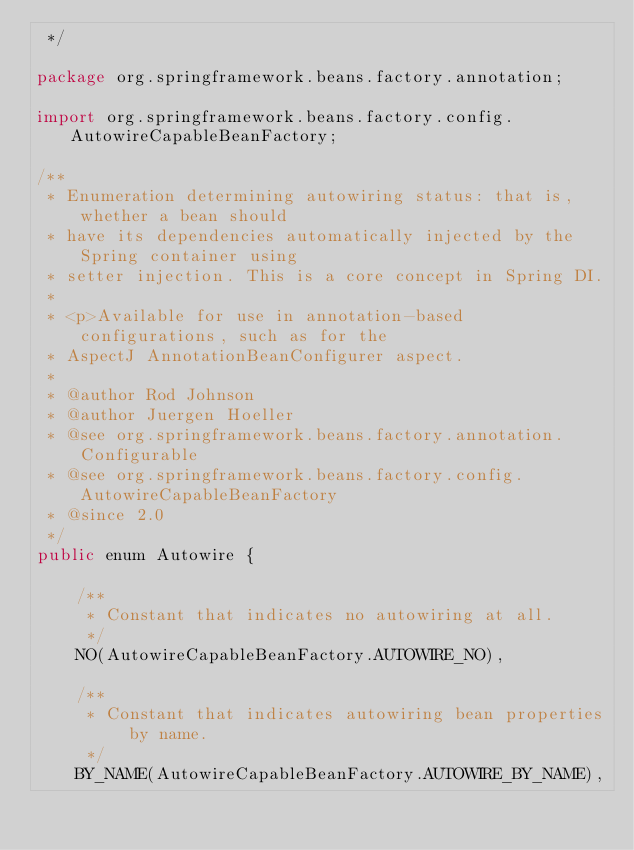<code> <loc_0><loc_0><loc_500><loc_500><_Java_> */

package org.springframework.beans.factory.annotation;

import org.springframework.beans.factory.config.AutowireCapableBeanFactory;

/**
 * Enumeration determining autowiring status: that is, whether a bean should
 * have its dependencies automatically injected by the Spring container using
 * setter injection. This is a core concept in Spring DI.
 *
 * <p>Available for use in annotation-based configurations, such as for the
 * AspectJ AnnotationBeanConfigurer aspect.
 *
 * @author Rod Johnson
 * @author Juergen Hoeller
 * @see org.springframework.beans.factory.annotation.Configurable
 * @see org.springframework.beans.factory.config.AutowireCapableBeanFactory
 * @since 2.0
 */
public enum Autowire {

    /**
     * Constant that indicates no autowiring at all.
     */
    NO(AutowireCapableBeanFactory.AUTOWIRE_NO),

    /**
     * Constant that indicates autowiring bean properties by name.
     */
    BY_NAME(AutowireCapableBeanFactory.AUTOWIRE_BY_NAME),
</code> 